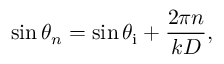<formula> <loc_0><loc_0><loc_500><loc_500>\sin \theta _ { n } = \sin \theta _ { i } + \frac { 2 \pi n } { k D } ,</formula> 